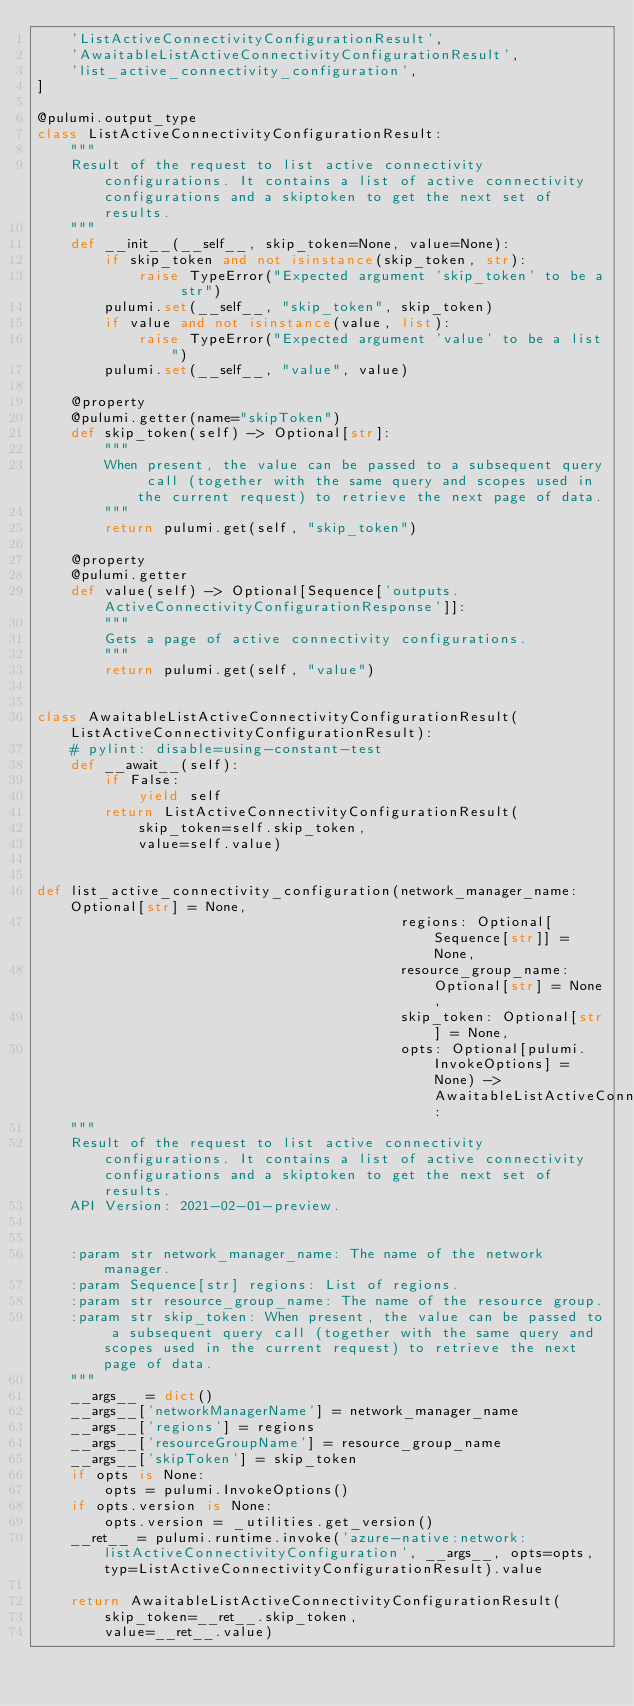<code> <loc_0><loc_0><loc_500><loc_500><_Python_>    'ListActiveConnectivityConfigurationResult',
    'AwaitableListActiveConnectivityConfigurationResult',
    'list_active_connectivity_configuration',
]

@pulumi.output_type
class ListActiveConnectivityConfigurationResult:
    """
    Result of the request to list active connectivity configurations. It contains a list of active connectivity configurations and a skiptoken to get the next set of results.
    """
    def __init__(__self__, skip_token=None, value=None):
        if skip_token and not isinstance(skip_token, str):
            raise TypeError("Expected argument 'skip_token' to be a str")
        pulumi.set(__self__, "skip_token", skip_token)
        if value and not isinstance(value, list):
            raise TypeError("Expected argument 'value' to be a list")
        pulumi.set(__self__, "value", value)

    @property
    @pulumi.getter(name="skipToken")
    def skip_token(self) -> Optional[str]:
        """
        When present, the value can be passed to a subsequent query call (together with the same query and scopes used in the current request) to retrieve the next page of data.
        """
        return pulumi.get(self, "skip_token")

    @property
    @pulumi.getter
    def value(self) -> Optional[Sequence['outputs.ActiveConnectivityConfigurationResponse']]:
        """
        Gets a page of active connectivity configurations.
        """
        return pulumi.get(self, "value")


class AwaitableListActiveConnectivityConfigurationResult(ListActiveConnectivityConfigurationResult):
    # pylint: disable=using-constant-test
    def __await__(self):
        if False:
            yield self
        return ListActiveConnectivityConfigurationResult(
            skip_token=self.skip_token,
            value=self.value)


def list_active_connectivity_configuration(network_manager_name: Optional[str] = None,
                                           regions: Optional[Sequence[str]] = None,
                                           resource_group_name: Optional[str] = None,
                                           skip_token: Optional[str] = None,
                                           opts: Optional[pulumi.InvokeOptions] = None) -> AwaitableListActiveConnectivityConfigurationResult:
    """
    Result of the request to list active connectivity configurations. It contains a list of active connectivity configurations and a skiptoken to get the next set of results.
    API Version: 2021-02-01-preview.


    :param str network_manager_name: The name of the network manager.
    :param Sequence[str] regions: List of regions.
    :param str resource_group_name: The name of the resource group.
    :param str skip_token: When present, the value can be passed to a subsequent query call (together with the same query and scopes used in the current request) to retrieve the next page of data.
    """
    __args__ = dict()
    __args__['networkManagerName'] = network_manager_name
    __args__['regions'] = regions
    __args__['resourceGroupName'] = resource_group_name
    __args__['skipToken'] = skip_token
    if opts is None:
        opts = pulumi.InvokeOptions()
    if opts.version is None:
        opts.version = _utilities.get_version()
    __ret__ = pulumi.runtime.invoke('azure-native:network:listActiveConnectivityConfiguration', __args__, opts=opts, typ=ListActiveConnectivityConfigurationResult).value

    return AwaitableListActiveConnectivityConfigurationResult(
        skip_token=__ret__.skip_token,
        value=__ret__.value)
</code> 